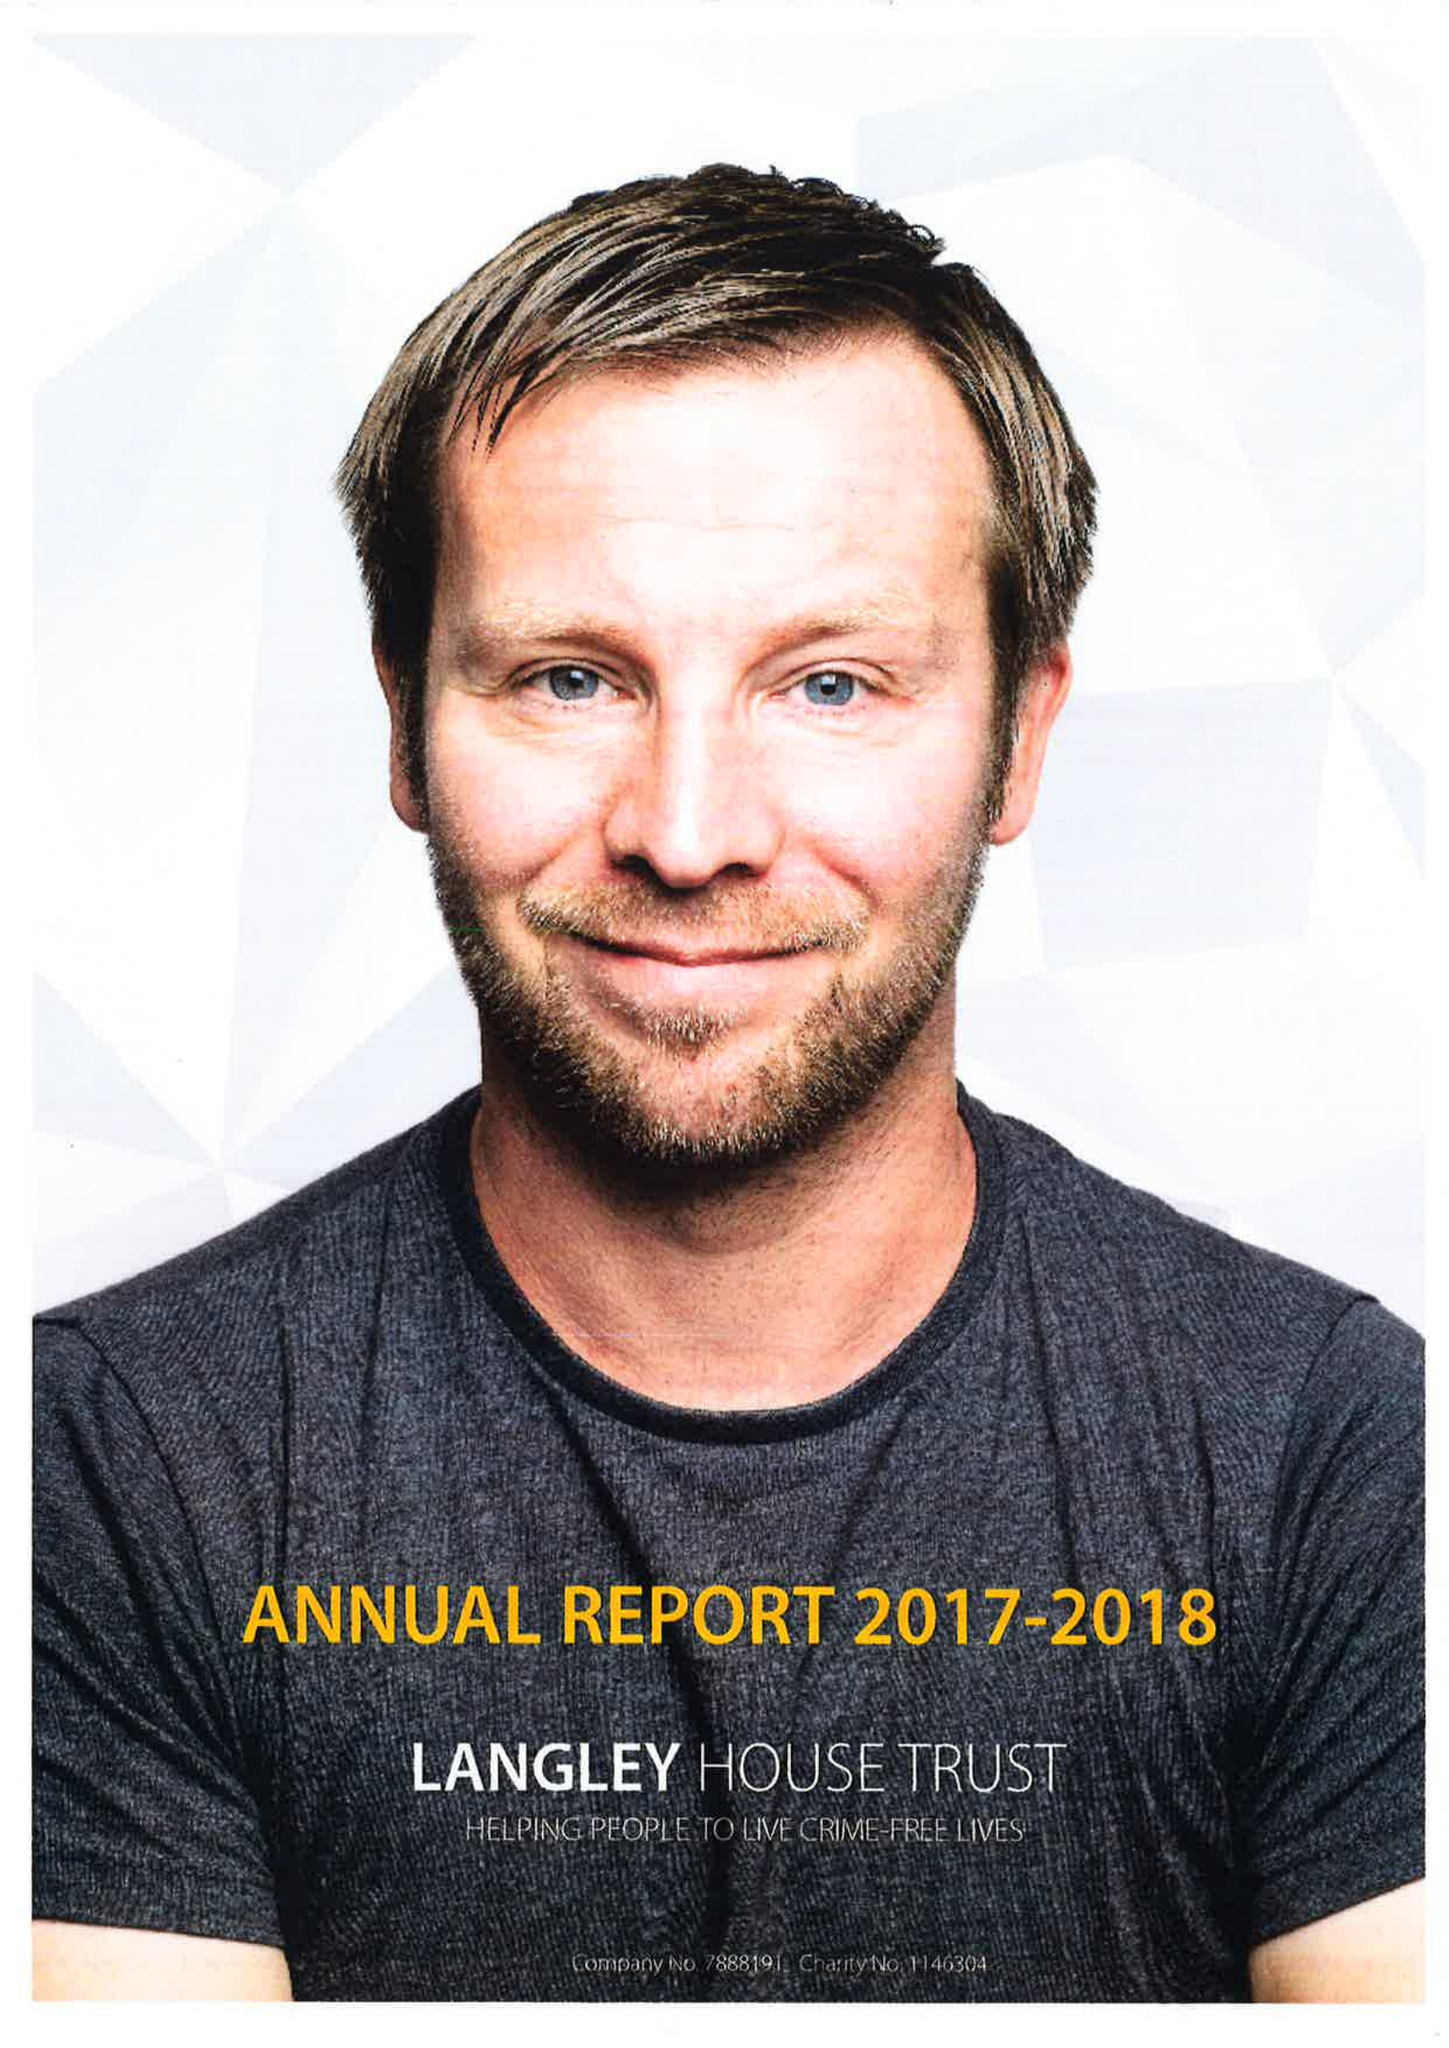What is the value for the address__postcode?
Answer the question using a single word or phrase. CV2 2QJ 